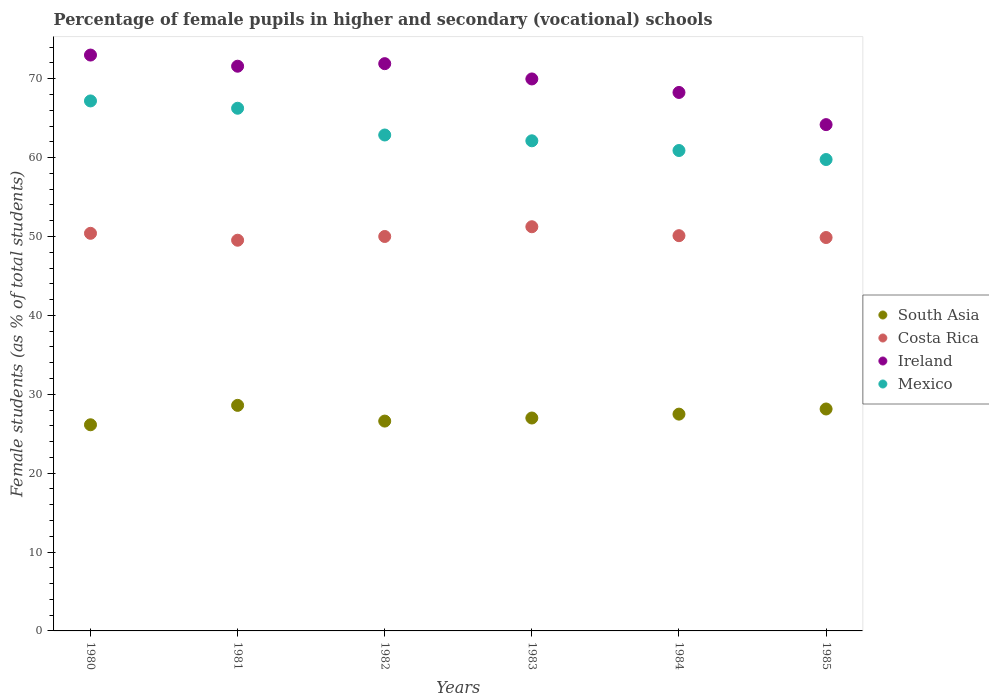How many different coloured dotlines are there?
Your answer should be compact. 4. Is the number of dotlines equal to the number of legend labels?
Offer a very short reply. Yes. Across all years, what is the maximum percentage of female pupils in higher and secondary schools in Costa Rica?
Your answer should be very brief. 51.24. Across all years, what is the minimum percentage of female pupils in higher and secondary schools in South Asia?
Your response must be concise. 26.13. What is the total percentage of female pupils in higher and secondary schools in Costa Rica in the graph?
Ensure brevity in your answer.  301.13. What is the difference between the percentage of female pupils in higher and secondary schools in South Asia in 1983 and that in 1985?
Your answer should be compact. -1.14. What is the difference between the percentage of female pupils in higher and secondary schools in South Asia in 1985 and the percentage of female pupils in higher and secondary schools in Ireland in 1981?
Your response must be concise. -43.45. What is the average percentage of female pupils in higher and secondary schools in Mexico per year?
Make the answer very short. 63.18. In the year 1984, what is the difference between the percentage of female pupils in higher and secondary schools in Costa Rica and percentage of female pupils in higher and secondary schools in South Asia?
Offer a terse response. 22.62. In how many years, is the percentage of female pupils in higher and secondary schools in Costa Rica greater than 20 %?
Give a very brief answer. 6. What is the ratio of the percentage of female pupils in higher and secondary schools in Ireland in 1982 to that in 1983?
Your answer should be compact. 1.03. Is the percentage of female pupils in higher and secondary schools in Ireland in 1982 less than that in 1984?
Give a very brief answer. No. What is the difference between the highest and the second highest percentage of female pupils in higher and secondary schools in South Asia?
Make the answer very short. 0.46. What is the difference between the highest and the lowest percentage of female pupils in higher and secondary schools in South Asia?
Ensure brevity in your answer.  2.46. Is the sum of the percentage of female pupils in higher and secondary schools in Ireland in 1983 and 1984 greater than the maximum percentage of female pupils in higher and secondary schools in South Asia across all years?
Provide a short and direct response. Yes. Is it the case that in every year, the sum of the percentage of female pupils in higher and secondary schools in Ireland and percentage of female pupils in higher and secondary schools in South Asia  is greater than the percentage of female pupils in higher and secondary schools in Mexico?
Your answer should be compact. Yes. Is the percentage of female pupils in higher and secondary schools in Mexico strictly less than the percentage of female pupils in higher and secondary schools in Ireland over the years?
Provide a succinct answer. Yes. How many dotlines are there?
Offer a very short reply. 4. What is the difference between two consecutive major ticks on the Y-axis?
Your answer should be very brief. 10. Are the values on the major ticks of Y-axis written in scientific E-notation?
Your answer should be very brief. No. Does the graph contain grids?
Provide a succinct answer. No. What is the title of the graph?
Ensure brevity in your answer.  Percentage of female pupils in higher and secondary (vocational) schools. Does "Tajikistan" appear as one of the legend labels in the graph?
Make the answer very short. No. What is the label or title of the Y-axis?
Your answer should be compact. Female students (as % of total students). What is the Female students (as % of total students) in South Asia in 1980?
Keep it short and to the point. 26.13. What is the Female students (as % of total students) of Costa Rica in 1980?
Provide a short and direct response. 50.4. What is the Female students (as % of total students) in Ireland in 1980?
Keep it short and to the point. 73. What is the Female students (as % of total students) in Mexico in 1980?
Your answer should be compact. 67.18. What is the Female students (as % of total students) in South Asia in 1981?
Your response must be concise. 28.59. What is the Female students (as % of total students) in Costa Rica in 1981?
Your answer should be compact. 49.53. What is the Female students (as % of total students) in Ireland in 1981?
Your answer should be compact. 71.58. What is the Female students (as % of total students) in Mexico in 1981?
Make the answer very short. 66.26. What is the Female students (as % of total students) of South Asia in 1982?
Your answer should be compact. 26.6. What is the Female students (as % of total students) in Ireland in 1982?
Your answer should be compact. 71.91. What is the Female students (as % of total students) of Mexico in 1982?
Give a very brief answer. 62.87. What is the Female students (as % of total students) of South Asia in 1983?
Your answer should be compact. 26.99. What is the Female students (as % of total students) in Costa Rica in 1983?
Ensure brevity in your answer.  51.24. What is the Female students (as % of total students) in Ireland in 1983?
Keep it short and to the point. 69.97. What is the Female students (as % of total students) in Mexico in 1983?
Keep it short and to the point. 62.13. What is the Female students (as % of total students) in South Asia in 1984?
Provide a short and direct response. 27.48. What is the Female students (as % of total students) of Costa Rica in 1984?
Offer a very short reply. 50.1. What is the Female students (as % of total students) of Ireland in 1984?
Your answer should be very brief. 68.26. What is the Female students (as % of total students) in Mexico in 1984?
Your answer should be compact. 60.9. What is the Female students (as % of total students) in South Asia in 1985?
Offer a terse response. 28.13. What is the Female students (as % of total students) in Costa Rica in 1985?
Your answer should be very brief. 49.87. What is the Female students (as % of total students) of Ireland in 1985?
Keep it short and to the point. 64.18. What is the Female students (as % of total students) of Mexico in 1985?
Provide a short and direct response. 59.76. Across all years, what is the maximum Female students (as % of total students) of South Asia?
Your answer should be compact. 28.59. Across all years, what is the maximum Female students (as % of total students) in Costa Rica?
Your answer should be very brief. 51.24. Across all years, what is the maximum Female students (as % of total students) in Ireland?
Your answer should be compact. 73. Across all years, what is the maximum Female students (as % of total students) of Mexico?
Provide a short and direct response. 67.18. Across all years, what is the minimum Female students (as % of total students) in South Asia?
Your response must be concise. 26.13. Across all years, what is the minimum Female students (as % of total students) of Costa Rica?
Ensure brevity in your answer.  49.53. Across all years, what is the minimum Female students (as % of total students) of Ireland?
Your answer should be compact. 64.18. Across all years, what is the minimum Female students (as % of total students) in Mexico?
Offer a very short reply. 59.76. What is the total Female students (as % of total students) in South Asia in the graph?
Your answer should be very brief. 163.93. What is the total Female students (as % of total students) in Costa Rica in the graph?
Your response must be concise. 301.13. What is the total Female students (as % of total students) in Ireland in the graph?
Offer a very short reply. 418.9. What is the total Female students (as % of total students) in Mexico in the graph?
Provide a succinct answer. 379.09. What is the difference between the Female students (as % of total students) of South Asia in 1980 and that in 1981?
Keep it short and to the point. -2.46. What is the difference between the Female students (as % of total students) of Costa Rica in 1980 and that in 1981?
Ensure brevity in your answer.  0.88. What is the difference between the Female students (as % of total students) in Ireland in 1980 and that in 1981?
Provide a short and direct response. 1.41. What is the difference between the Female students (as % of total students) of Mexico in 1980 and that in 1981?
Ensure brevity in your answer.  0.93. What is the difference between the Female students (as % of total students) in South Asia in 1980 and that in 1982?
Your answer should be compact. -0.47. What is the difference between the Female students (as % of total students) of Costa Rica in 1980 and that in 1982?
Offer a terse response. 0.4. What is the difference between the Female students (as % of total students) in Ireland in 1980 and that in 1982?
Ensure brevity in your answer.  1.09. What is the difference between the Female students (as % of total students) in Mexico in 1980 and that in 1982?
Give a very brief answer. 4.32. What is the difference between the Female students (as % of total students) of South Asia in 1980 and that in 1983?
Your response must be concise. -0.86. What is the difference between the Female students (as % of total students) in Costa Rica in 1980 and that in 1983?
Offer a terse response. -0.83. What is the difference between the Female students (as % of total students) in Ireland in 1980 and that in 1983?
Give a very brief answer. 3.03. What is the difference between the Female students (as % of total students) of Mexico in 1980 and that in 1983?
Give a very brief answer. 5.05. What is the difference between the Female students (as % of total students) in South Asia in 1980 and that in 1984?
Make the answer very short. -1.35. What is the difference between the Female students (as % of total students) of Costa Rica in 1980 and that in 1984?
Your answer should be compact. 0.3. What is the difference between the Female students (as % of total students) in Ireland in 1980 and that in 1984?
Your response must be concise. 4.74. What is the difference between the Female students (as % of total students) of Mexico in 1980 and that in 1984?
Offer a terse response. 6.28. What is the difference between the Female students (as % of total students) of South Asia in 1980 and that in 1985?
Offer a terse response. -2. What is the difference between the Female students (as % of total students) of Costa Rica in 1980 and that in 1985?
Offer a very short reply. 0.53. What is the difference between the Female students (as % of total students) in Ireland in 1980 and that in 1985?
Offer a very short reply. 8.82. What is the difference between the Female students (as % of total students) of Mexico in 1980 and that in 1985?
Your answer should be compact. 7.43. What is the difference between the Female students (as % of total students) of South Asia in 1981 and that in 1982?
Your response must be concise. 1.99. What is the difference between the Female students (as % of total students) of Costa Rica in 1981 and that in 1982?
Keep it short and to the point. -0.47. What is the difference between the Female students (as % of total students) in Ireland in 1981 and that in 1982?
Your answer should be compact. -0.32. What is the difference between the Female students (as % of total students) of Mexico in 1981 and that in 1982?
Offer a very short reply. 3.39. What is the difference between the Female students (as % of total students) in South Asia in 1981 and that in 1983?
Offer a very short reply. 1.6. What is the difference between the Female students (as % of total students) of Costa Rica in 1981 and that in 1983?
Offer a very short reply. -1.71. What is the difference between the Female students (as % of total students) of Ireland in 1981 and that in 1983?
Your answer should be very brief. 1.61. What is the difference between the Female students (as % of total students) in Mexico in 1981 and that in 1983?
Provide a short and direct response. 4.13. What is the difference between the Female students (as % of total students) of South Asia in 1981 and that in 1984?
Your response must be concise. 1.11. What is the difference between the Female students (as % of total students) in Costa Rica in 1981 and that in 1984?
Your response must be concise. -0.58. What is the difference between the Female students (as % of total students) in Ireland in 1981 and that in 1984?
Provide a short and direct response. 3.33. What is the difference between the Female students (as % of total students) of Mexico in 1981 and that in 1984?
Your answer should be compact. 5.36. What is the difference between the Female students (as % of total students) in South Asia in 1981 and that in 1985?
Offer a very short reply. 0.46. What is the difference between the Female students (as % of total students) of Costa Rica in 1981 and that in 1985?
Your answer should be compact. -0.34. What is the difference between the Female students (as % of total students) in Ireland in 1981 and that in 1985?
Keep it short and to the point. 7.4. What is the difference between the Female students (as % of total students) in Mexico in 1981 and that in 1985?
Make the answer very short. 6.5. What is the difference between the Female students (as % of total students) of South Asia in 1982 and that in 1983?
Ensure brevity in your answer.  -0.39. What is the difference between the Female students (as % of total students) of Costa Rica in 1982 and that in 1983?
Offer a terse response. -1.24. What is the difference between the Female students (as % of total students) of Ireland in 1982 and that in 1983?
Ensure brevity in your answer.  1.94. What is the difference between the Female students (as % of total students) of Mexico in 1982 and that in 1983?
Offer a terse response. 0.74. What is the difference between the Female students (as % of total students) in South Asia in 1982 and that in 1984?
Keep it short and to the point. -0.88. What is the difference between the Female students (as % of total students) of Costa Rica in 1982 and that in 1984?
Your response must be concise. -0.1. What is the difference between the Female students (as % of total students) in Ireland in 1982 and that in 1984?
Provide a succinct answer. 3.65. What is the difference between the Female students (as % of total students) in Mexico in 1982 and that in 1984?
Offer a terse response. 1.97. What is the difference between the Female students (as % of total students) in South Asia in 1982 and that in 1985?
Make the answer very short. -1.53. What is the difference between the Female students (as % of total students) of Costa Rica in 1982 and that in 1985?
Make the answer very short. 0.13. What is the difference between the Female students (as % of total students) in Ireland in 1982 and that in 1985?
Make the answer very short. 7.73. What is the difference between the Female students (as % of total students) of Mexico in 1982 and that in 1985?
Make the answer very short. 3.11. What is the difference between the Female students (as % of total students) in South Asia in 1983 and that in 1984?
Provide a short and direct response. -0.49. What is the difference between the Female students (as % of total students) of Costa Rica in 1983 and that in 1984?
Ensure brevity in your answer.  1.13. What is the difference between the Female students (as % of total students) of Ireland in 1983 and that in 1984?
Your response must be concise. 1.71. What is the difference between the Female students (as % of total students) of Mexico in 1983 and that in 1984?
Make the answer very short. 1.23. What is the difference between the Female students (as % of total students) of South Asia in 1983 and that in 1985?
Keep it short and to the point. -1.14. What is the difference between the Female students (as % of total students) in Costa Rica in 1983 and that in 1985?
Ensure brevity in your answer.  1.37. What is the difference between the Female students (as % of total students) of Ireland in 1983 and that in 1985?
Make the answer very short. 5.79. What is the difference between the Female students (as % of total students) in Mexico in 1983 and that in 1985?
Your answer should be compact. 2.37. What is the difference between the Female students (as % of total students) in South Asia in 1984 and that in 1985?
Provide a succinct answer. -0.65. What is the difference between the Female students (as % of total students) of Costa Rica in 1984 and that in 1985?
Your answer should be very brief. 0.23. What is the difference between the Female students (as % of total students) in Ireland in 1984 and that in 1985?
Your answer should be very brief. 4.08. What is the difference between the Female students (as % of total students) of Mexico in 1984 and that in 1985?
Keep it short and to the point. 1.14. What is the difference between the Female students (as % of total students) of South Asia in 1980 and the Female students (as % of total students) of Costa Rica in 1981?
Give a very brief answer. -23.39. What is the difference between the Female students (as % of total students) in South Asia in 1980 and the Female students (as % of total students) in Ireland in 1981?
Provide a succinct answer. -45.45. What is the difference between the Female students (as % of total students) of South Asia in 1980 and the Female students (as % of total students) of Mexico in 1981?
Provide a succinct answer. -40.12. What is the difference between the Female students (as % of total students) of Costa Rica in 1980 and the Female students (as % of total students) of Ireland in 1981?
Provide a succinct answer. -21.18. What is the difference between the Female students (as % of total students) of Costa Rica in 1980 and the Female students (as % of total students) of Mexico in 1981?
Provide a succinct answer. -15.85. What is the difference between the Female students (as % of total students) in Ireland in 1980 and the Female students (as % of total students) in Mexico in 1981?
Keep it short and to the point. 6.74. What is the difference between the Female students (as % of total students) in South Asia in 1980 and the Female students (as % of total students) in Costa Rica in 1982?
Offer a very short reply. -23.87. What is the difference between the Female students (as % of total students) of South Asia in 1980 and the Female students (as % of total students) of Ireland in 1982?
Your answer should be very brief. -45.78. What is the difference between the Female students (as % of total students) of South Asia in 1980 and the Female students (as % of total students) of Mexico in 1982?
Offer a very short reply. -36.73. What is the difference between the Female students (as % of total students) of Costa Rica in 1980 and the Female students (as % of total students) of Ireland in 1982?
Your answer should be very brief. -21.51. What is the difference between the Female students (as % of total students) of Costa Rica in 1980 and the Female students (as % of total students) of Mexico in 1982?
Offer a terse response. -12.46. What is the difference between the Female students (as % of total students) in Ireland in 1980 and the Female students (as % of total students) in Mexico in 1982?
Keep it short and to the point. 10.13. What is the difference between the Female students (as % of total students) of South Asia in 1980 and the Female students (as % of total students) of Costa Rica in 1983?
Offer a terse response. -25.1. What is the difference between the Female students (as % of total students) in South Asia in 1980 and the Female students (as % of total students) in Ireland in 1983?
Provide a succinct answer. -43.84. What is the difference between the Female students (as % of total students) in South Asia in 1980 and the Female students (as % of total students) in Mexico in 1983?
Give a very brief answer. -36. What is the difference between the Female students (as % of total students) in Costa Rica in 1980 and the Female students (as % of total students) in Ireland in 1983?
Give a very brief answer. -19.57. What is the difference between the Female students (as % of total students) in Costa Rica in 1980 and the Female students (as % of total students) in Mexico in 1983?
Make the answer very short. -11.73. What is the difference between the Female students (as % of total students) in Ireland in 1980 and the Female students (as % of total students) in Mexico in 1983?
Make the answer very short. 10.87. What is the difference between the Female students (as % of total students) in South Asia in 1980 and the Female students (as % of total students) in Costa Rica in 1984?
Offer a very short reply. -23.97. What is the difference between the Female students (as % of total students) in South Asia in 1980 and the Female students (as % of total students) in Ireland in 1984?
Ensure brevity in your answer.  -42.13. What is the difference between the Female students (as % of total students) of South Asia in 1980 and the Female students (as % of total students) of Mexico in 1984?
Keep it short and to the point. -34.77. What is the difference between the Female students (as % of total students) in Costa Rica in 1980 and the Female students (as % of total students) in Ireland in 1984?
Offer a terse response. -17.86. What is the difference between the Female students (as % of total students) of Costa Rica in 1980 and the Female students (as % of total students) of Mexico in 1984?
Offer a terse response. -10.5. What is the difference between the Female students (as % of total students) of Ireland in 1980 and the Female students (as % of total students) of Mexico in 1984?
Offer a terse response. 12.1. What is the difference between the Female students (as % of total students) of South Asia in 1980 and the Female students (as % of total students) of Costa Rica in 1985?
Your answer should be compact. -23.74. What is the difference between the Female students (as % of total students) in South Asia in 1980 and the Female students (as % of total students) in Ireland in 1985?
Offer a terse response. -38.05. What is the difference between the Female students (as % of total students) in South Asia in 1980 and the Female students (as % of total students) in Mexico in 1985?
Keep it short and to the point. -33.62. What is the difference between the Female students (as % of total students) of Costa Rica in 1980 and the Female students (as % of total students) of Ireland in 1985?
Keep it short and to the point. -13.78. What is the difference between the Female students (as % of total students) of Costa Rica in 1980 and the Female students (as % of total students) of Mexico in 1985?
Ensure brevity in your answer.  -9.35. What is the difference between the Female students (as % of total students) of Ireland in 1980 and the Female students (as % of total students) of Mexico in 1985?
Your response must be concise. 13.24. What is the difference between the Female students (as % of total students) in South Asia in 1981 and the Female students (as % of total students) in Costa Rica in 1982?
Ensure brevity in your answer.  -21.41. What is the difference between the Female students (as % of total students) of South Asia in 1981 and the Female students (as % of total students) of Ireland in 1982?
Keep it short and to the point. -43.32. What is the difference between the Female students (as % of total students) in South Asia in 1981 and the Female students (as % of total students) in Mexico in 1982?
Make the answer very short. -34.27. What is the difference between the Female students (as % of total students) of Costa Rica in 1981 and the Female students (as % of total students) of Ireland in 1982?
Ensure brevity in your answer.  -22.38. What is the difference between the Female students (as % of total students) in Costa Rica in 1981 and the Female students (as % of total students) in Mexico in 1982?
Provide a short and direct response. -13.34. What is the difference between the Female students (as % of total students) of Ireland in 1981 and the Female students (as % of total students) of Mexico in 1982?
Offer a terse response. 8.72. What is the difference between the Female students (as % of total students) in South Asia in 1981 and the Female students (as % of total students) in Costa Rica in 1983?
Your answer should be compact. -22.64. What is the difference between the Female students (as % of total students) in South Asia in 1981 and the Female students (as % of total students) in Ireland in 1983?
Offer a terse response. -41.38. What is the difference between the Female students (as % of total students) of South Asia in 1981 and the Female students (as % of total students) of Mexico in 1983?
Provide a succinct answer. -33.54. What is the difference between the Female students (as % of total students) of Costa Rica in 1981 and the Female students (as % of total students) of Ireland in 1983?
Ensure brevity in your answer.  -20.44. What is the difference between the Female students (as % of total students) of Costa Rica in 1981 and the Female students (as % of total students) of Mexico in 1983?
Your response must be concise. -12.6. What is the difference between the Female students (as % of total students) of Ireland in 1981 and the Female students (as % of total students) of Mexico in 1983?
Keep it short and to the point. 9.46. What is the difference between the Female students (as % of total students) of South Asia in 1981 and the Female students (as % of total students) of Costa Rica in 1984?
Keep it short and to the point. -21.51. What is the difference between the Female students (as % of total students) in South Asia in 1981 and the Female students (as % of total students) in Ireland in 1984?
Keep it short and to the point. -39.67. What is the difference between the Female students (as % of total students) in South Asia in 1981 and the Female students (as % of total students) in Mexico in 1984?
Provide a succinct answer. -32.31. What is the difference between the Female students (as % of total students) in Costa Rica in 1981 and the Female students (as % of total students) in Ireland in 1984?
Your answer should be very brief. -18.73. What is the difference between the Female students (as % of total students) in Costa Rica in 1981 and the Female students (as % of total students) in Mexico in 1984?
Provide a short and direct response. -11.37. What is the difference between the Female students (as % of total students) of Ireland in 1981 and the Female students (as % of total students) of Mexico in 1984?
Make the answer very short. 10.69. What is the difference between the Female students (as % of total students) of South Asia in 1981 and the Female students (as % of total students) of Costa Rica in 1985?
Keep it short and to the point. -21.28. What is the difference between the Female students (as % of total students) in South Asia in 1981 and the Female students (as % of total students) in Ireland in 1985?
Provide a short and direct response. -35.59. What is the difference between the Female students (as % of total students) of South Asia in 1981 and the Female students (as % of total students) of Mexico in 1985?
Make the answer very short. -31.16. What is the difference between the Female students (as % of total students) in Costa Rica in 1981 and the Female students (as % of total students) in Ireland in 1985?
Provide a short and direct response. -14.65. What is the difference between the Female students (as % of total students) of Costa Rica in 1981 and the Female students (as % of total students) of Mexico in 1985?
Your answer should be very brief. -10.23. What is the difference between the Female students (as % of total students) of Ireland in 1981 and the Female students (as % of total students) of Mexico in 1985?
Give a very brief answer. 11.83. What is the difference between the Female students (as % of total students) of South Asia in 1982 and the Female students (as % of total students) of Costa Rica in 1983?
Provide a short and direct response. -24.64. What is the difference between the Female students (as % of total students) of South Asia in 1982 and the Female students (as % of total students) of Ireland in 1983?
Make the answer very short. -43.37. What is the difference between the Female students (as % of total students) in South Asia in 1982 and the Female students (as % of total students) in Mexico in 1983?
Provide a short and direct response. -35.53. What is the difference between the Female students (as % of total students) of Costa Rica in 1982 and the Female students (as % of total students) of Ireland in 1983?
Keep it short and to the point. -19.97. What is the difference between the Female students (as % of total students) of Costa Rica in 1982 and the Female students (as % of total students) of Mexico in 1983?
Provide a short and direct response. -12.13. What is the difference between the Female students (as % of total students) in Ireland in 1982 and the Female students (as % of total students) in Mexico in 1983?
Your answer should be compact. 9.78. What is the difference between the Female students (as % of total students) of South Asia in 1982 and the Female students (as % of total students) of Costa Rica in 1984?
Offer a terse response. -23.5. What is the difference between the Female students (as % of total students) of South Asia in 1982 and the Female students (as % of total students) of Ireland in 1984?
Your response must be concise. -41.66. What is the difference between the Female students (as % of total students) in South Asia in 1982 and the Female students (as % of total students) in Mexico in 1984?
Your answer should be compact. -34.3. What is the difference between the Female students (as % of total students) in Costa Rica in 1982 and the Female students (as % of total students) in Ireland in 1984?
Give a very brief answer. -18.26. What is the difference between the Female students (as % of total students) of Costa Rica in 1982 and the Female students (as % of total students) of Mexico in 1984?
Your answer should be very brief. -10.9. What is the difference between the Female students (as % of total students) in Ireland in 1982 and the Female students (as % of total students) in Mexico in 1984?
Keep it short and to the point. 11.01. What is the difference between the Female students (as % of total students) of South Asia in 1982 and the Female students (as % of total students) of Costa Rica in 1985?
Offer a very short reply. -23.27. What is the difference between the Female students (as % of total students) in South Asia in 1982 and the Female students (as % of total students) in Ireland in 1985?
Offer a very short reply. -37.58. What is the difference between the Female students (as % of total students) in South Asia in 1982 and the Female students (as % of total students) in Mexico in 1985?
Your answer should be compact. -33.16. What is the difference between the Female students (as % of total students) in Costa Rica in 1982 and the Female students (as % of total students) in Ireland in 1985?
Ensure brevity in your answer.  -14.18. What is the difference between the Female students (as % of total students) in Costa Rica in 1982 and the Female students (as % of total students) in Mexico in 1985?
Keep it short and to the point. -9.76. What is the difference between the Female students (as % of total students) in Ireland in 1982 and the Female students (as % of total students) in Mexico in 1985?
Offer a very short reply. 12.15. What is the difference between the Female students (as % of total students) of South Asia in 1983 and the Female students (as % of total students) of Costa Rica in 1984?
Provide a succinct answer. -23.11. What is the difference between the Female students (as % of total students) of South Asia in 1983 and the Female students (as % of total students) of Ireland in 1984?
Provide a short and direct response. -41.27. What is the difference between the Female students (as % of total students) in South Asia in 1983 and the Female students (as % of total students) in Mexico in 1984?
Keep it short and to the point. -33.91. What is the difference between the Female students (as % of total students) in Costa Rica in 1983 and the Female students (as % of total students) in Ireland in 1984?
Your answer should be compact. -17.02. What is the difference between the Female students (as % of total students) of Costa Rica in 1983 and the Female students (as % of total students) of Mexico in 1984?
Provide a succinct answer. -9.66. What is the difference between the Female students (as % of total students) in Ireland in 1983 and the Female students (as % of total students) in Mexico in 1984?
Your answer should be compact. 9.07. What is the difference between the Female students (as % of total students) in South Asia in 1983 and the Female students (as % of total students) in Costa Rica in 1985?
Give a very brief answer. -22.88. What is the difference between the Female students (as % of total students) in South Asia in 1983 and the Female students (as % of total students) in Ireland in 1985?
Give a very brief answer. -37.19. What is the difference between the Female students (as % of total students) in South Asia in 1983 and the Female students (as % of total students) in Mexico in 1985?
Make the answer very short. -32.77. What is the difference between the Female students (as % of total students) of Costa Rica in 1983 and the Female students (as % of total students) of Ireland in 1985?
Keep it short and to the point. -12.94. What is the difference between the Female students (as % of total students) of Costa Rica in 1983 and the Female students (as % of total students) of Mexico in 1985?
Provide a short and direct response. -8.52. What is the difference between the Female students (as % of total students) of Ireland in 1983 and the Female students (as % of total students) of Mexico in 1985?
Your response must be concise. 10.21. What is the difference between the Female students (as % of total students) of South Asia in 1984 and the Female students (as % of total students) of Costa Rica in 1985?
Your response must be concise. -22.39. What is the difference between the Female students (as % of total students) in South Asia in 1984 and the Female students (as % of total students) in Ireland in 1985?
Keep it short and to the point. -36.7. What is the difference between the Female students (as % of total students) in South Asia in 1984 and the Female students (as % of total students) in Mexico in 1985?
Offer a very short reply. -32.28. What is the difference between the Female students (as % of total students) in Costa Rica in 1984 and the Female students (as % of total students) in Ireland in 1985?
Make the answer very short. -14.08. What is the difference between the Female students (as % of total students) of Costa Rica in 1984 and the Female students (as % of total students) of Mexico in 1985?
Ensure brevity in your answer.  -9.65. What is the difference between the Female students (as % of total students) of Ireland in 1984 and the Female students (as % of total students) of Mexico in 1985?
Ensure brevity in your answer.  8.5. What is the average Female students (as % of total students) of South Asia per year?
Your response must be concise. 27.32. What is the average Female students (as % of total students) in Costa Rica per year?
Your response must be concise. 50.19. What is the average Female students (as % of total students) in Ireland per year?
Offer a terse response. 69.82. What is the average Female students (as % of total students) in Mexico per year?
Provide a short and direct response. 63.18. In the year 1980, what is the difference between the Female students (as % of total students) in South Asia and Female students (as % of total students) in Costa Rica?
Your answer should be compact. -24.27. In the year 1980, what is the difference between the Female students (as % of total students) of South Asia and Female students (as % of total students) of Ireland?
Give a very brief answer. -46.87. In the year 1980, what is the difference between the Female students (as % of total students) in South Asia and Female students (as % of total students) in Mexico?
Your answer should be very brief. -41.05. In the year 1980, what is the difference between the Female students (as % of total students) in Costa Rica and Female students (as % of total students) in Ireland?
Offer a very short reply. -22.6. In the year 1980, what is the difference between the Female students (as % of total students) in Costa Rica and Female students (as % of total students) in Mexico?
Provide a short and direct response. -16.78. In the year 1980, what is the difference between the Female students (as % of total students) of Ireland and Female students (as % of total students) of Mexico?
Provide a short and direct response. 5.82. In the year 1981, what is the difference between the Female students (as % of total students) in South Asia and Female students (as % of total students) in Costa Rica?
Your response must be concise. -20.93. In the year 1981, what is the difference between the Female students (as % of total students) of South Asia and Female students (as % of total students) of Ireland?
Provide a succinct answer. -42.99. In the year 1981, what is the difference between the Female students (as % of total students) in South Asia and Female students (as % of total students) in Mexico?
Provide a succinct answer. -37.66. In the year 1981, what is the difference between the Female students (as % of total students) in Costa Rica and Female students (as % of total students) in Ireland?
Provide a succinct answer. -22.06. In the year 1981, what is the difference between the Female students (as % of total students) in Costa Rica and Female students (as % of total students) in Mexico?
Offer a very short reply. -16.73. In the year 1981, what is the difference between the Female students (as % of total students) in Ireland and Female students (as % of total students) in Mexico?
Make the answer very short. 5.33. In the year 1982, what is the difference between the Female students (as % of total students) of South Asia and Female students (as % of total students) of Costa Rica?
Your answer should be very brief. -23.4. In the year 1982, what is the difference between the Female students (as % of total students) in South Asia and Female students (as % of total students) in Ireland?
Ensure brevity in your answer.  -45.31. In the year 1982, what is the difference between the Female students (as % of total students) in South Asia and Female students (as % of total students) in Mexico?
Provide a short and direct response. -36.27. In the year 1982, what is the difference between the Female students (as % of total students) of Costa Rica and Female students (as % of total students) of Ireland?
Offer a terse response. -21.91. In the year 1982, what is the difference between the Female students (as % of total students) of Costa Rica and Female students (as % of total students) of Mexico?
Your answer should be compact. -12.87. In the year 1982, what is the difference between the Female students (as % of total students) of Ireland and Female students (as % of total students) of Mexico?
Offer a very short reply. 9.04. In the year 1983, what is the difference between the Female students (as % of total students) in South Asia and Female students (as % of total students) in Costa Rica?
Your response must be concise. -24.25. In the year 1983, what is the difference between the Female students (as % of total students) of South Asia and Female students (as % of total students) of Ireland?
Offer a very short reply. -42.98. In the year 1983, what is the difference between the Female students (as % of total students) of South Asia and Female students (as % of total students) of Mexico?
Ensure brevity in your answer.  -35.14. In the year 1983, what is the difference between the Female students (as % of total students) of Costa Rica and Female students (as % of total students) of Ireland?
Provide a succinct answer. -18.74. In the year 1983, what is the difference between the Female students (as % of total students) of Costa Rica and Female students (as % of total students) of Mexico?
Offer a very short reply. -10.89. In the year 1983, what is the difference between the Female students (as % of total students) in Ireland and Female students (as % of total students) in Mexico?
Your answer should be compact. 7.84. In the year 1984, what is the difference between the Female students (as % of total students) in South Asia and Female students (as % of total students) in Costa Rica?
Offer a very short reply. -22.62. In the year 1984, what is the difference between the Female students (as % of total students) of South Asia and Female students (as % of total students) of Ireland?
Offer a very short reply. -40.78. In the year 1984, what is the difference between the Female students (as % of total students) of South Asia and Female students (as % of total students) of Mexico?
Your answer should be compact. -33.42. In the year 1984, what is the difference between the Female students (as % of total students) in Costa Rica and Female students (as % of total students) in Ireland?
Provide a short and direct response. -18.16. In the year 1984, what is the difference between the Female students (as % of total students) in Costa Rica and Female students (as % of total students) in Mexico?
Give a very brief answer. -10.8. In the year 1984, what is the difference between the Female students (as % of total students) in Ireland and Female students (as % of total students) in Mexico?
Provide a succinct answer. 7.36. In the year 1985, what is the difference between the Female students (as % of total students) of South Asia and Female students (as % of total students) of Costa Rica?
Give a very brief answer. -21.74. In the year 1985, what is the difference between the Female students (as % of total students) in South Asia and Female students (as % of total students) in Ireland?
Your answer should be compact. -36.05. In the year 1985, what is the difference between the Female students (as % of total students) of South Asia and Female students (as % of total students) of Mexico?
Keep it short and to the point. -31.62. In the year 1985, what is the difference between the Female students (as % of total students) in Costa Rica and Female students (as % of total students) in Ireland?
Keep it short and to the point. -14.31. In the year 1985, what is the difference between the Female students (as % of total students) in Costa Rica and Female students (as % of total students) in Mexico?
Your answer should be very brief. -9.89. In the year 1985, what is the difference between the Female students (as % of total students) of Ireland and Female students (as % of total students) of Mexico?
Offer a terse response. 4.42. What is the ratio of the Female students (as % of total students) in South Asia in 1980 to that in 1981?
Ensure brevity in your answer.  0.91. What is the ratio of the Female students (as % of total students) of Costa Rica in 1980 to that in 1981?
Provide a short and direct response. 1.02. What is the ratio of the Female students (as % of total students) of Ireland in 1980 to that in 1981?
Ensure brevity in your answer.  1.02. What is the ratio of the Female students (as % of total students) of South Asia in 1980 to that in 1982?
Your answer should be compact. 0.98. What is the ratio of the Female students (as % of total students) in Costa Rica in 1980 to that in 1982?
Keep it short and to the point. 1.01. What is the ratio of the Female students (as % of total students) of Ireland in 1980 to that in 1982?
Your response must be concise. 1.02. What is the ratio of the Female students (as % of total students) in Mexico in 1980 to that in 1982?
Your response must be concise. 1.07. What is the ratio of the Female students (as % of total students) of South Asia in 1980 to that in 1983?
Keep it short and to the point. 0.97. What is the ratio of the Female students (as % of total students) in Costa Rica in 1980 to that in 1983?
Keep it short and to the point. 0.98. What is the ratio of the Female students (as % of total students) in Ireland in 1980 to that in 1983?
Keep it short and to the point. 1.04. What is the ratio of the Female students (as % of total students) in Mexico in 1980 to that in 1983?
Your response must be concise. 1.08. What is the ratio of the Female students (as % of total students) in South Asia in 1980 to that in 1984?
Provide a succinct answer. 0.95. What is the ratio of the Female students (as % of total students) of Ireland in 1980 to that in 1984?
Your response must be concise. 1.07. What is the ratio of the Female students (as % of total students) in Mexico in 1980 to that in 1984?
Your answer should be very brief. 1.1. What is the ratio of the Female students (as % of total students) of South Asia in 1980 to that in 1985?
Your response must be concise. 0.93. What is the ratio of the Female students (as % of total students) in Costa Rica in 1980 to that in 1985?
Your answer should be compact. 1.01. What is the ratio of the Female students (as % of total students) in Ireland in 1980 to that in 1985?
Keep it short and to the point. 1.14. What is the ratio of the Female students (as % of total students) of Mexico in 1980 to that in 1985?
Keep it short and to the point. 1.12. What is the ratio of the Female students (as % of total students) of South Asia in 1981 to that in 1982?
Provide a short and direct response. 1.07. What is the ratio of the Female students (as % of total students) of Costa Rica in 1981 to that in 1982?
Provide a short and direct response. 0.99. What is the ratio of the Female students (as % of total students) of Ireland in 1981 to that in 1982?
Make the answer very short. 1. What is the ratio of the Female students (as % of total students) of Mexico in 1981 to that in 1982?
Offer a very short reply. 1.05. What is the ratio of the Female students (as % of total students) of South Asia in 1981 to that in 1983?
Make the answer very short. 1.06. What is the ratio of the Female students (as % of total students) in Costa Rica in 1981 to that in 1983?
Your answer should be compact. 0.97. What is the ratio of the Female students (as % of total students) of Ireland in 1981 to that in 1983?
Make the answer very short. 1.02. What is the ratio of the Female students (as % of total students) of Mexico in 1981 to that in 1983?
Offer a very short reply. 1.07. What is the ratio of the Female students (as % of total students) of South Asia in 1981 to that in 1984?
Keep it short and to the point. 1.04. What is the ratio of the Female students (as % of total students) of Costa Rica in 1981 to that in 1984?
Your answer should be very brief. 0.99. What is the ratio of the Female students (as % of total students) in Ireland in 1981 to that in 1984?
Offer a terse response. 1.05. What is the ratio of the Female students (as % of total students) in Mexico in 1981 to that in 1984?
Make the answer very short. 1.09. What is the ratio of the Female students (as % of total students) of South Asia in 1981 to that in 1985?
Provide a succinct answer. 1.02. What is the ratio of the Female students (as % of total students) in Costa Rica in 1981 to that in 1985?
Give a very brief answer. 0.99. What is the ratio of the Female students (as % of total students) in Ireland in 1981 to that in 1985?
Offer a very short reply. 1.12. What is the ratio of the Female students (as % of total students) of Mexico in 1981 to that in 1985?
Keep it short and to the point. 1.11. What is the ratio of the Female students (as % of total students) in South Asia in 1982 to that in 1983?
Offer a very short reply. 0.99. What is the ratio of the Female students (as % of total students) of Costa Rica in 1982 to that in 1983?
Offer a very short reply. 0.98. What is the ratio of the Female students (as % of total students) in Ireland in 1982 to that in 1983?
Keep it short and to the point. 1.03. What is the ratio of the Female students (as % of total students) in Mexico in 1982 to that in 1983?
Your response must be concise. 1.01. What is the ratio of the Female students (as % of total students) of Costa Rica in 1982 to that in 1984?
Keep it short and to the point. 1. What is the ratio of the Female students (as % of total students) of Ireland in 1982 to that in 1984?
Your answer should be compact. 1.05. What is the ratio of the Female students (as % of total students) of Mexico in 1982 to that in 1984?
Your answer should be very brief. 1.03. What is the ratio of the Female students (as % of total students) in South Asia in 1982 to that in 1985?
Offer a terse response. 0.95. What is the ratio of the Female students (as % of total students) of Costa Rica in 1982 to that in 1985?
Your answer should be very brief. 1. What is the ratio of the Female students (as % of total students) in Ireland in 1982 to that in 1985?
Make the answer very short. 1.12. What is the ratio of the Female students (as % of total students) in Mexico in 1982 to that in 1985?
Your answer should be compact. 1.05. What is the ratio of the Female students (as % of total students) of South Asia in 1983 to that in 1984?
Give a very brief answer. 0.98. What is the ratio of the Female students (as % of total students) in Costa Rica in 1983 to that in 1984?
Offer a very short reply. 1.02. What is the ratio of the Female students (as % of total students) of Ireland in 1983 to that in 1984?
Offer a very short reply. 1.03. What is the ratio of the Female students (as % of total students) in Mexico in 1983 to that in 1984?
Your answer should be compact. 1.02. What is the ratio of the Female students (as % of total students) of South Asia in 1983 to that in 1985?
Provide a short and direct response. 0.96. What is the ratio of the Female students (as % of total students) in Costa Rica in 1983 to that in 1985?
Your answer should be compact. 1.03. What is the ratio of the Female students (as % of total students) in Ireland in 1983 to that in 1985?
Offer a very short reply. 1.09. What is the ratio of the Female students (as % of total students) of Mexico in 1983 to that in 1985?
Offer a very short reply. 1.04. What is the ratio of the Female students (as % of total students) of South Asia in 1984 to that in 1985?
Your response must be concise. 0.98. What is the ratio of the Female students (as % of total students) of Costa Rica in 1984 to that in 1985?
Provide a succinct answer. 1. What is the ratio of the Female students (as % of total students) in Ireland in 1984 to that in 1985?
Ensure brevity in your answer.  1.06. What is the ratio of the Female students (as % of total students) of Mexico in 1984 to that in 1985?
Provide a short and direct response. 1.02. What is the difference between the highest and the second highest Female students (as % of total students) in South Asia?
Your answer should be compact. 0.46. What is the difference between the highest and the second highest Female students (as % of total students) in Costa Rica?
Your answer should be compact. 0.83. What is the difference between the highest and the second highest Female students (as % of total students) in Ireland?
Give a very brief answer. 1.09. What is the difference between the highest and the second highest Female students (as % of total students) in Mexico?
Your answer should be very brief. 0.93. What is the difference between the highest and the lowest Female students (as % of total students) in South Asia?
Your answer should be compact. 2.46. What is the difference between the highest and the lowest Female students (as % of total students) of Costa Rica?
Ensure brevity in your answer.  1.71. What is the difference between the highest and the lowest Female students (as % of total students) of Ireland?
Keep it short and to the point. 8.82. What is the difference between the highest and the lowest Female students (as % of total students) in Mexico?
Offer a very short reply. 7.43. 